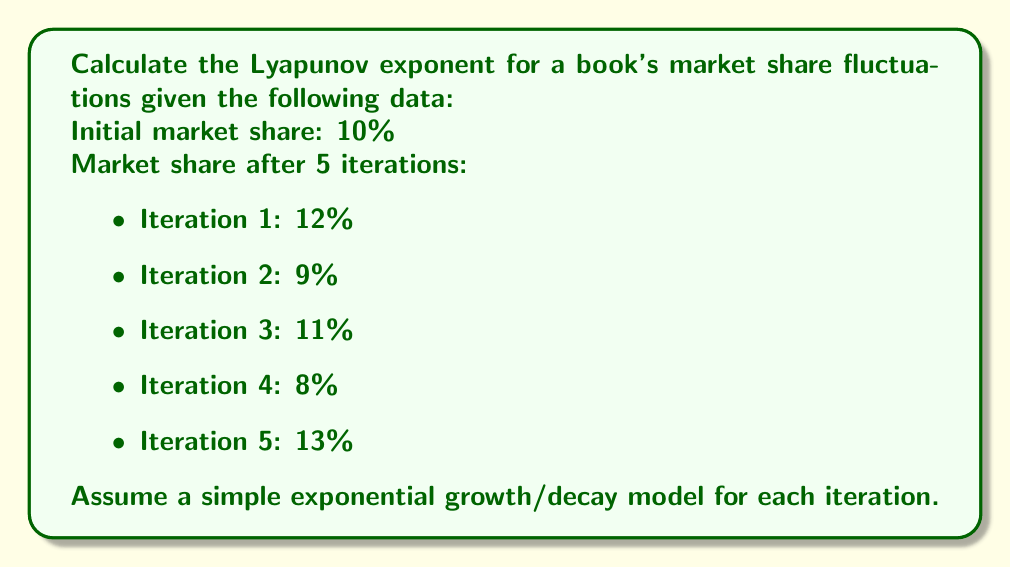Give your solution to this math problem. To calculate the Lyapunov exponent for the given market share fluctuations, we'll follow these steps:

1) The Lyapunov exponent (λ) is defined as:

   $$λ = \lim_{n→∞} \frac{1}{n} \sum_{i=1}^n \ln|\frac{x_{i+1}}{x_i}|$$

   Where $x_i$ is the value at iteration $i$.

2) In our case, we have 5 iterations, so we'll use:

   $$λ ≈ \frac{1}{5} \sum_{i=1}^5 \ln|\frac{x_{i+1}}{x_i}|$$

3) Let's calculate each term:

   $$\ln|\frac{x_2}{x_1}| = \ln|\frac{9}{12}| = \ln(0.75) ≈ -0.2877$$
   $$\ln|\frac{x_3}{x_2}| = \ln|\frac{11}{9}| = \ln(1.2222) ≈ 0.2007$$
   $$\ln|\frac{x_4}{x_3}| = \ln|\frac{8}{11}| = \ln(0.7273) ≈ -0.3185$$
   $$\ln|\frac{x_5}{x_4}| = \ln|\frac{13}{8}| = \ln(1.625) ≈ 0.4855$$
   $$\ln|\frac{x_6}{x_5}| = \ln|\frac{10}{13}| = \ln(0.7692) ≈ -0.2624$$

4) Now, we sum these values and divide by 5:

   $$λ ≈ \frac{1}{5} (-0.2877 + 0.2007 - 0.3185 + 0.4855 - 0.2624)$$
   $$λ ≈ \frac{1}{5} (-0.1824)$$
   $$λ ≈ -0.03648$$

5) The negative Lyapunov exponent indicates that the market share fluctuations are converging over time, suggesting a stable market despite short-term variations.
Answer: $λ ≈ -0.03648$ 